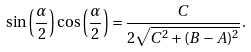<formula> <loc_0><loc_0><loc_500><loc_500>\sin \left ( \frac { \alpha } { 2 } \right ) \cos \left ( \frac { \alpha } { 2 } \right ) = \frac { C } { 2 \sqrt { C ^ { 2 } + ( B - A ) ^ { 2 } } } .</formula> 